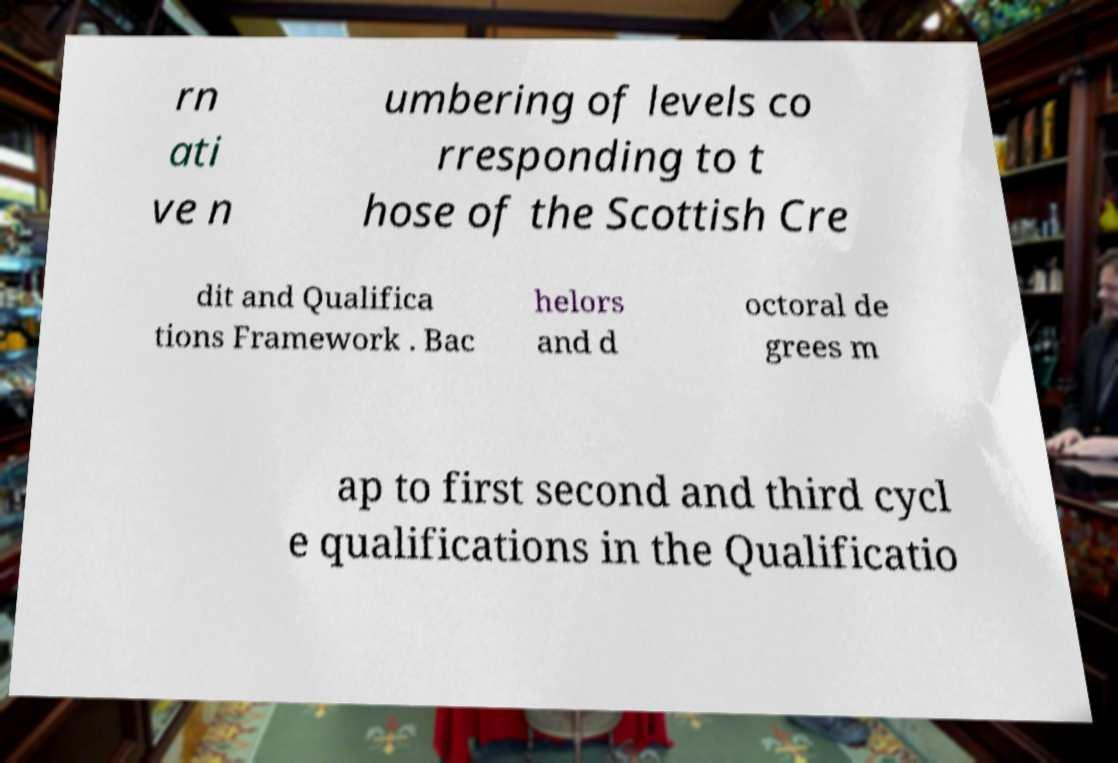Could you assist in decoding the text presented in this image and type it out clearly? rn ati ve n umbering of levels co rresponding to t hose of the Scottish Cre dit and Qualifica tions Framework . Bac helors and d octoral de grees m ap to first second and third cycl e qualifications in the Qualificatio 